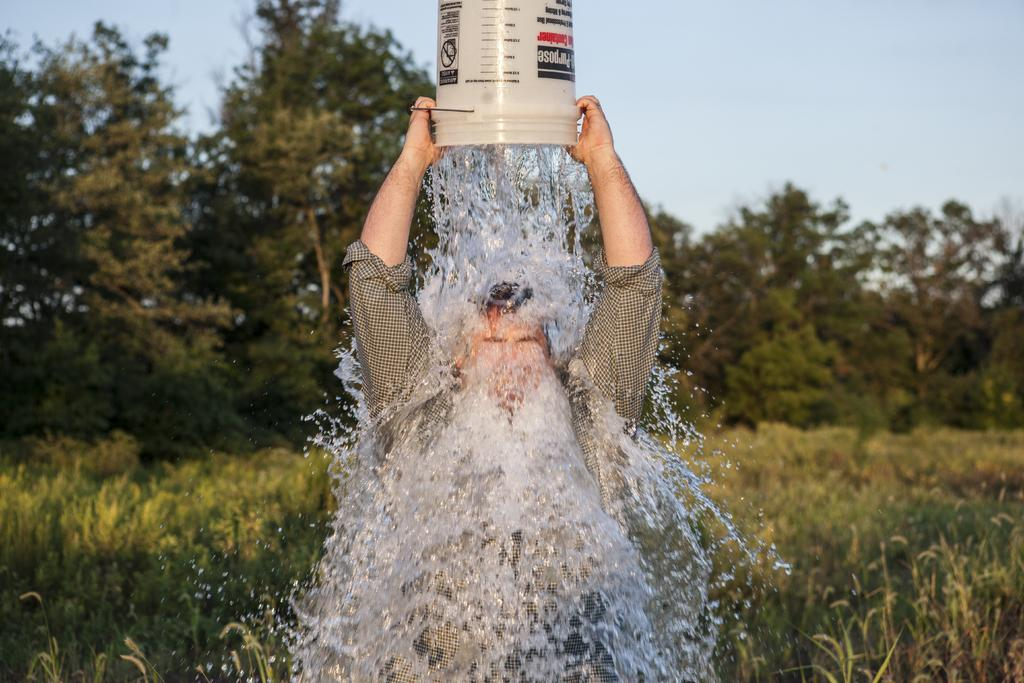Who is present in the image? There is a man in the image. What is the man doing in the image? The man is pouring water on himself. What object is the man holding in the image? The man is holding a bucket. What can be seen in the background of the image? There are plants and trees in the background of the image. Are there any fairies visible in the image? No, there are no fairies present in the image. What type of match is the man using to light the plants in the image? There is no match or fire present in the image; the man is simply pouring water on himself. 